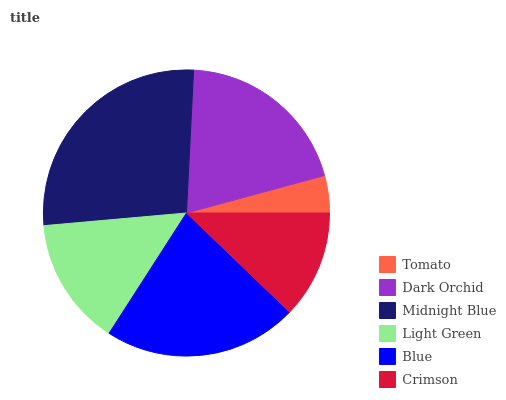Is Tomato the minimum?
Answer yes or no. Yes. Is Midnight Blue the maximum?
Answer yes or no. Yes. Is Dark Orchid the minimum?
Answer yes or no. No. Is Dark Orchid the maximum?
Answer yes or no. No. Is Dark Orchid greater than Tomato?
Answer yes or no. Yes. Is Tomato less than Dark Orchid?
Answer yes or no. Yes. Is Tomato greater than Dark Orchid?
Answer yes or no. No. Is Dark Orchid less than Tomato?
Answer yes or no. No. Is Dark Orchid the high median?
Answer yes or no. Yes. Is Light Green the low median?
Answer yes or no. Yes. Is Midnight Blue the high median?
Answer yes or no. No. Is Midnight Blue the low median?
Answer yes or no. No. 